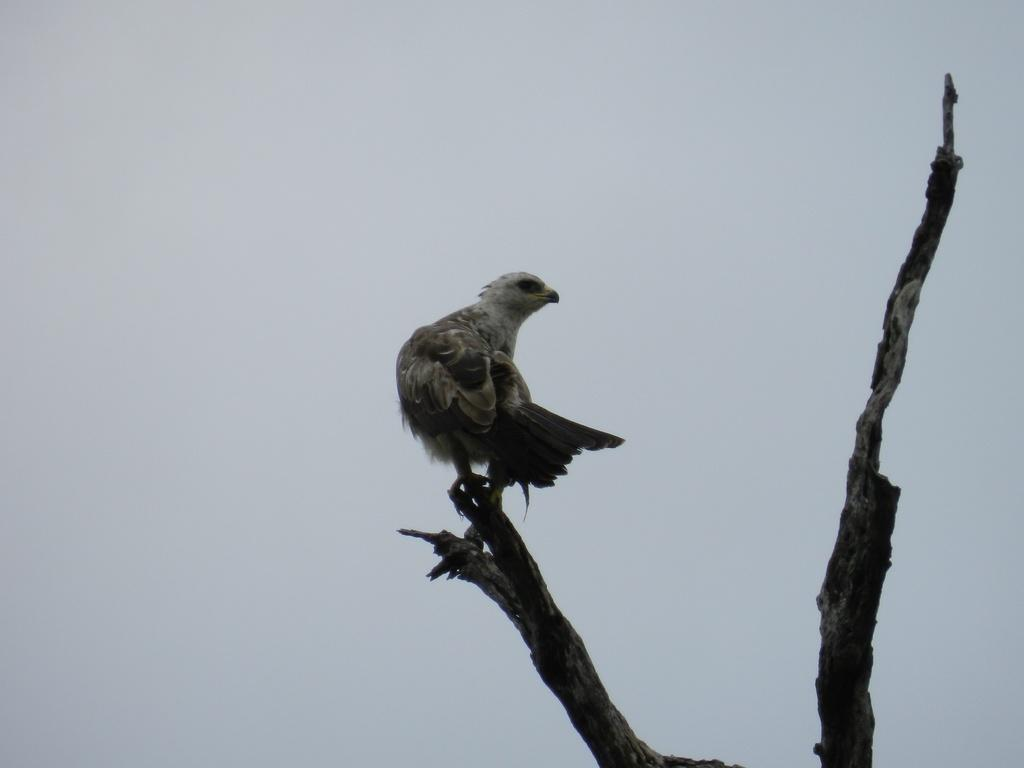What type of animal is in the image? There is a bird in the image. Where is the bird located in the image? The bird is sitting on a branch. Can you describe the bird's appearance? The bird has brown and white coloring. What can be seen in the background of the image? The sky is visible in the image. What colors are present in the sky? The sky has blue and white coloring. What type of lock is holding the bird's beak closed in the image? There is no lock present in the image, and the bird's beak is not closed. 